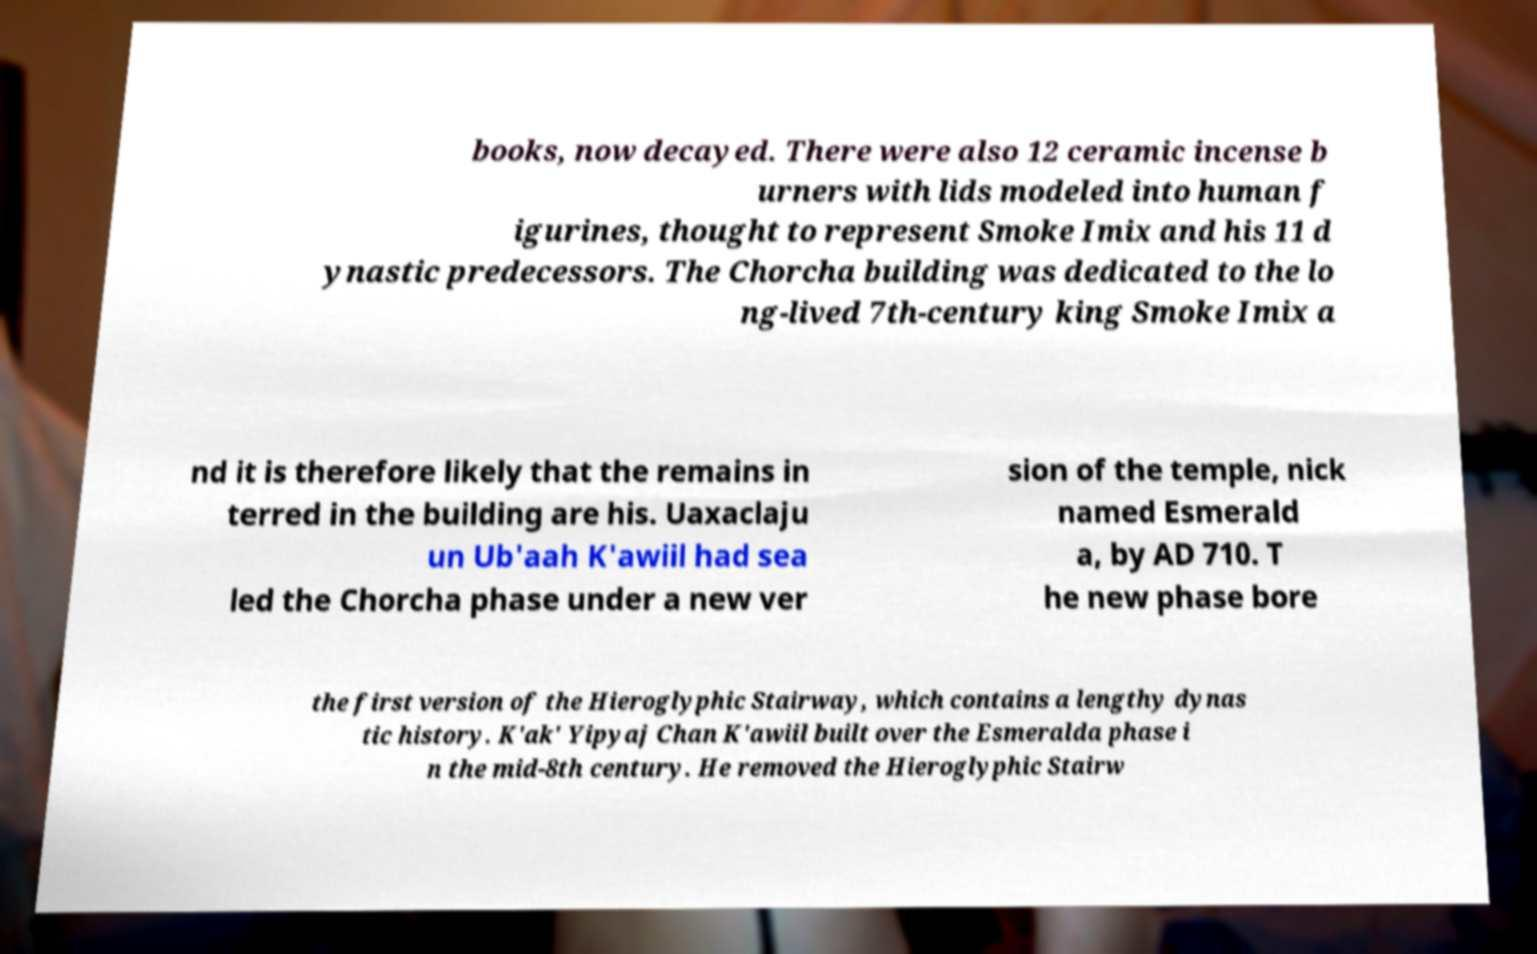I need the written content from this picture converted into text. Can you do that? books, now decayed. There were also 12 ceramic incense b urners with lids modeled into human f igurines, thought to represent Smoke Imix and his 11 d ynastic predecessors. The Chorcha building was dedicated to the lo ng-lived 7th-century king Smoke Imix a nd it is therefore likely that the remains in terred in the building are his. Uaxaclaju un Ub'aah K'awiil had sea led the Chorcha phase under a new ver sion of the temple, nick named Esmerald a, by AD 710. T he new phase bore the first version of the Hieroglyphic Stairway, which contains a lengthy dynas tic history. K'ak' Yipyaj Chan K'awiil built over the Esmeralda phase i n the mid-8th century. He removed the Hieroglyphic Stairw 